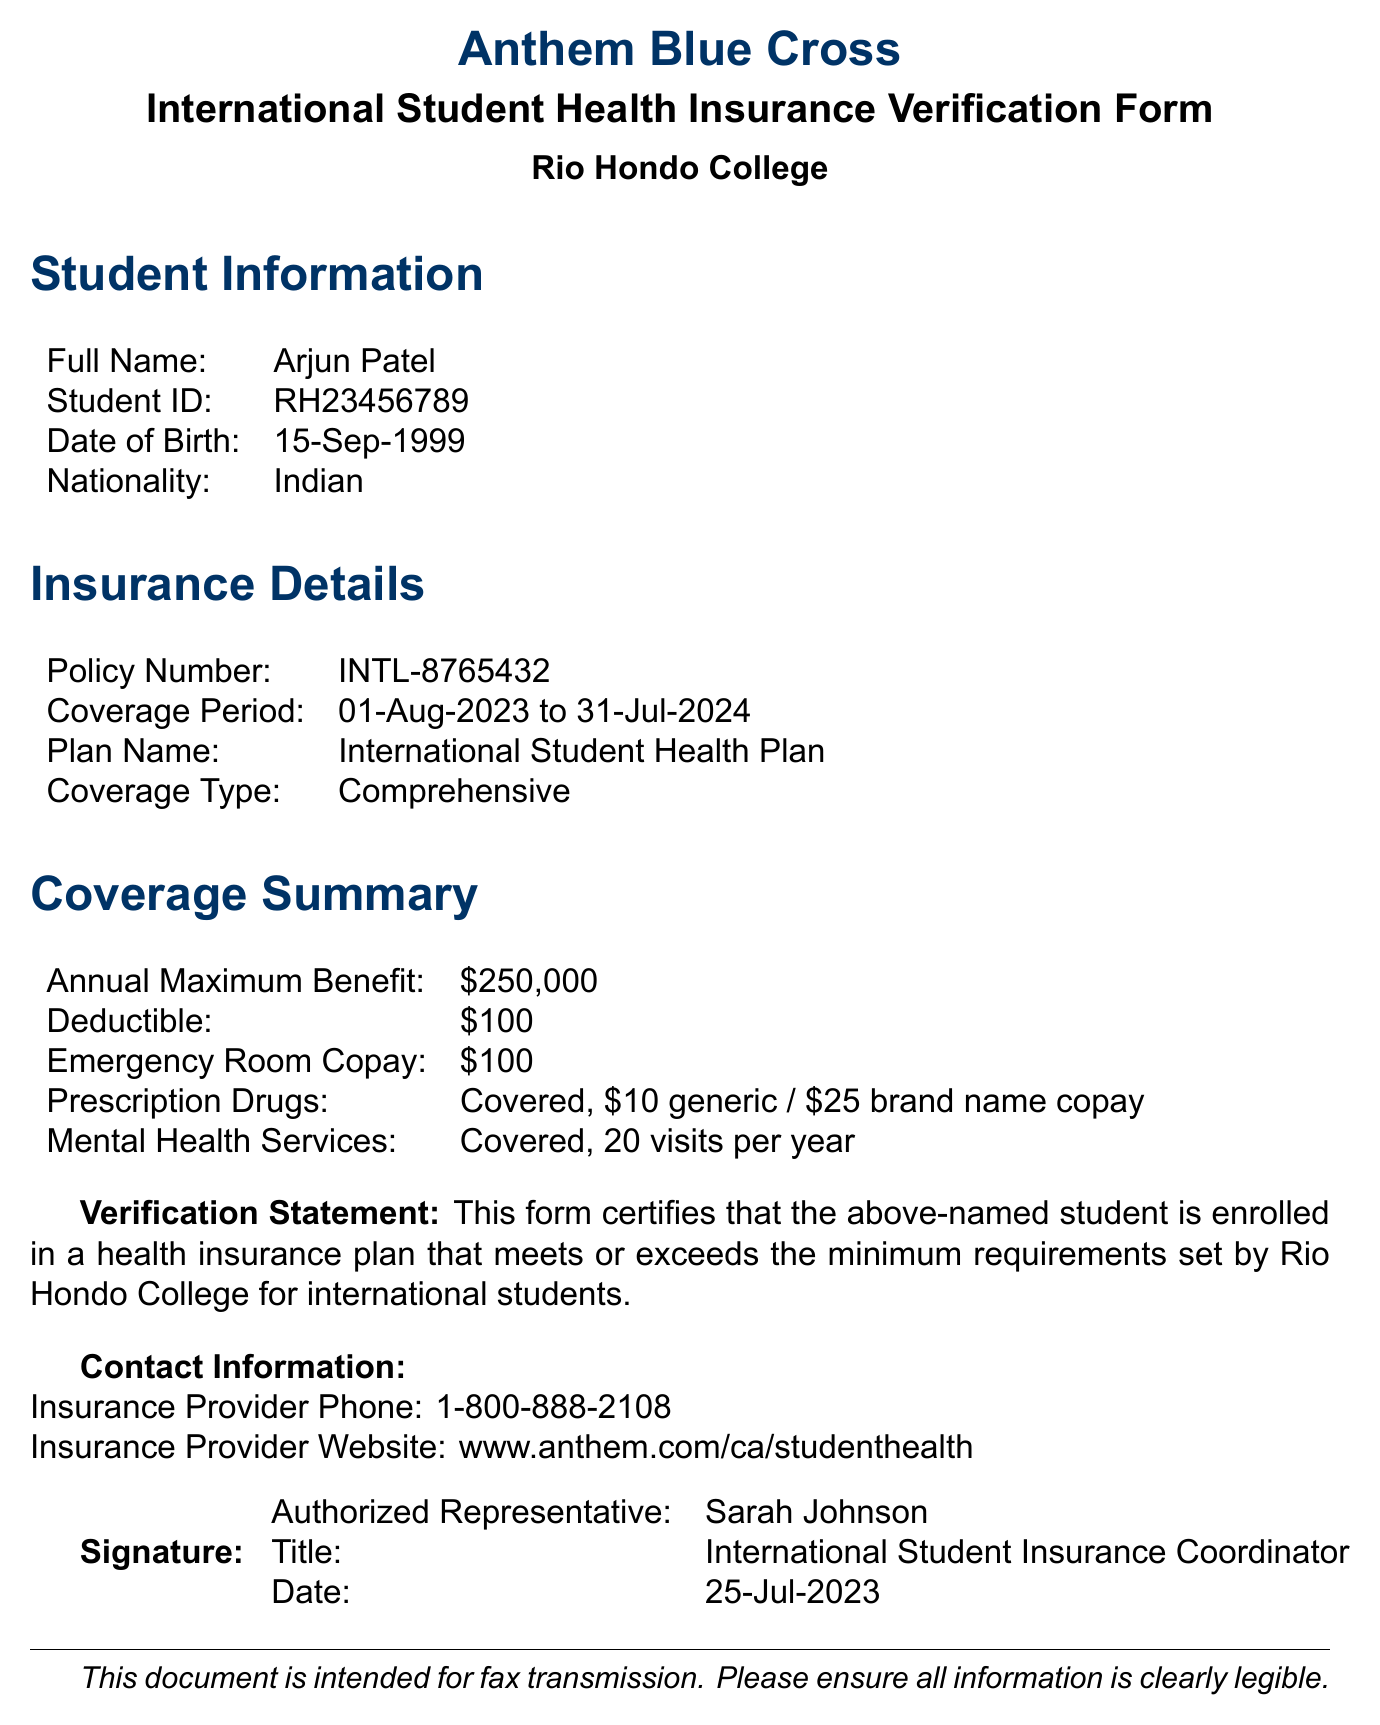What is the full name of the student? The document provides the student's full name section, which states: "Arjun Patel".
Answer: Arjun Patel What is the student ID? The student ID is listed in the Student Information section of the document, identified as "RH23456789".
Answer: RH23456789 What is the policy number? The policy number can be found in the Insurance Details section of the document, which states "INTL-8765432".
Answer: INTL-8765432 What is the coverage period? The coverage period is mentioned in the Insurance Details section, stating "01-Aug-2023 to 31-Jul-2024".
Answer: 01-Aug-2023 to 31-Jul-2024 What is the annual maximum benefit? The annual maximum benefit provided in the Coverage Summary section indicates "250,000".
Answer: $250,000 What is the deductible amount? The deductible is specified in the Coverage Summary section, which states "$100".
Answer: $100 How many mental health service visits are covered per year? The document states in the Coverage Summary that mental health services are covered for "20 visits per year".
Answer: 20 visits per year Who is the authorized representative? The authorized representative's name is provided at the end of the document as "Sarah Johnson".
Answer: Sarah Johnson What is the title of the authorized representative? The title of the authorized representative is mentioned in the signature section as "International Student Insurance Coordinator".
Answer: International Student Insurance Coordinator 